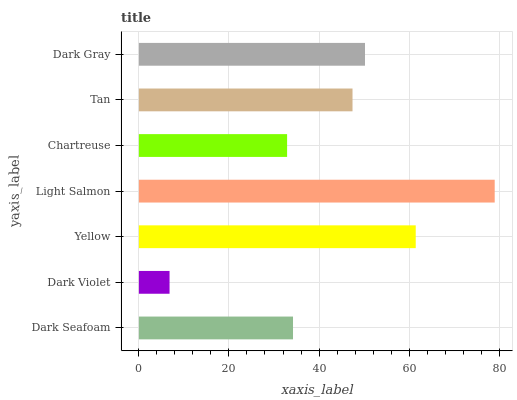Is Dark Violet the minimum?
Answer yes or no. Yes. Is Light Salmon the maximum?
Answer yes or no. Yes. Is Yellow the minimum?
Answer yes or no. No. Is Yellow the maximum?
Answer yes or no. No. Is Yellow greater than Dark Violet?
Answer yes or no. Yes. Is Dark Violet less than Yellow?
Answer yes or no. Yes. Is Dark Violet greater than Yellow?
Answer yes or no. No. Is Yellow less than Dark Violet?
Answer yes or no. No. Is Tan the high median?
Answer yes or no. Yes. Is Tan the low median?
Answer yes or no. Yes. Is Dark Violet the high median?
Answer yes or no. No. Is Dark Violet the low median?
Answer yes or no. No. 